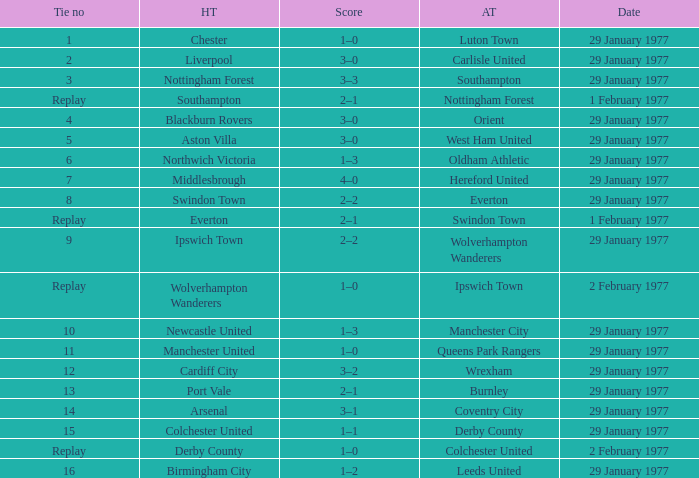What is the tie number when the home team is Port Vale? 13.0. 